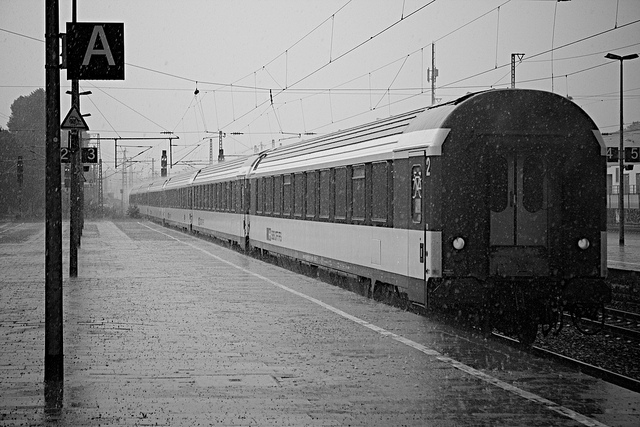Please identify all text content in this image. 2 3 A 2 5 4 